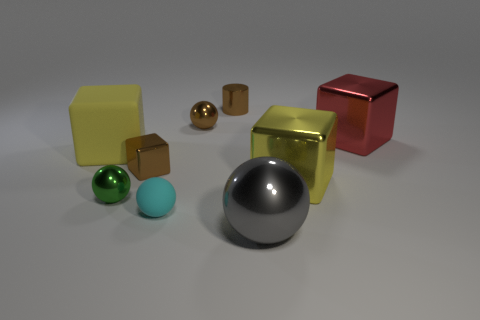Add 1 large red metallic cylinders. How many objects exist? 10 Subtract all spheres. How many objects are left? 5 Subtract all small metallic cylinders. Subtract all small matte things. How many objects are left? 7 Add 1 tiny brown cylinders. How many tiny brown cylinders are left? 2 Add 8 purple metallic objects. How many purple metallic objects exist? 8 Subtract 0 green blocks. How many objects are left? 9 